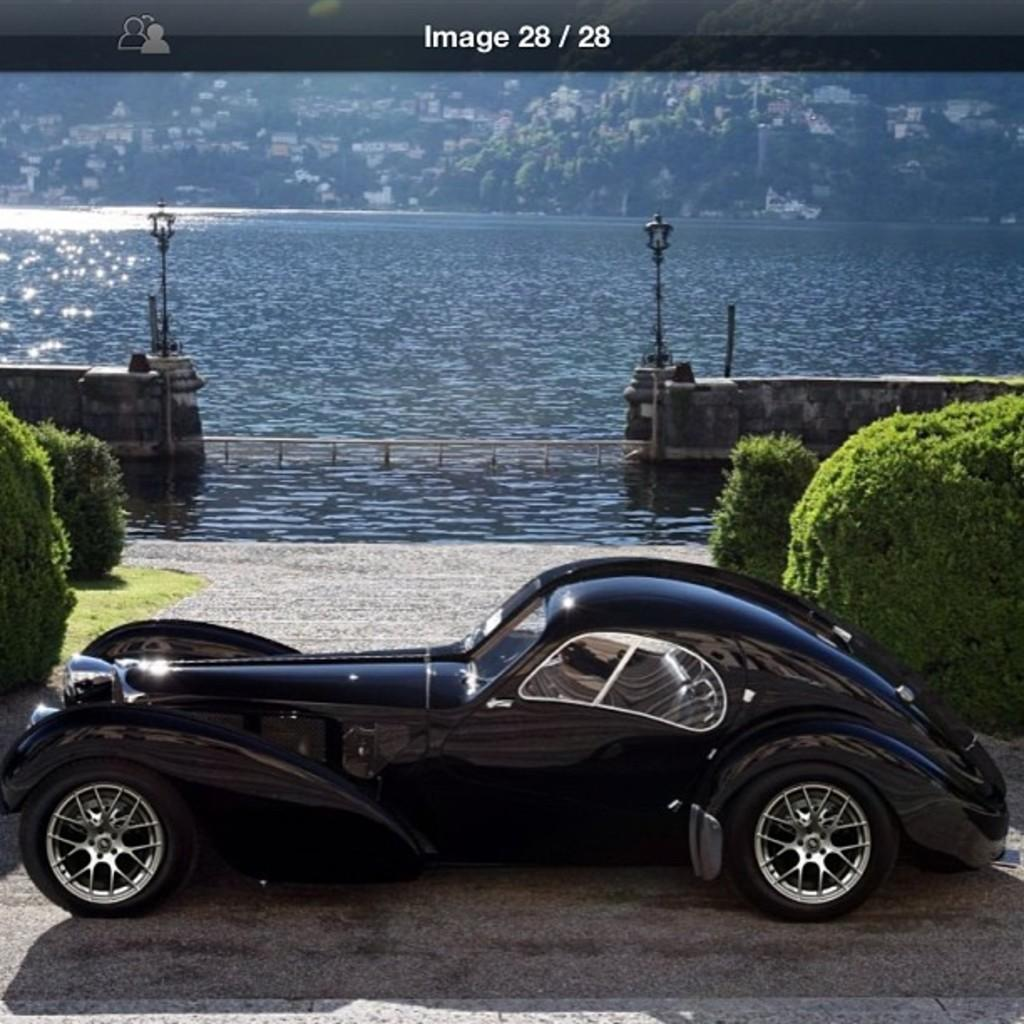What is the main object in the image? There is a screen in the image. What is shown on the screen? The screen displays a vehicle, plants, and water. What type of fencing is visible in the image? There is fencing visible in the image. What type of vegetation can be seen in the image? There are trees in the image. What type of structures can be seen in the image? There are buildings in the image. Can you tell me how many sisters are swimming in the image? There are no sisters or swimming activities depicted in the image. 